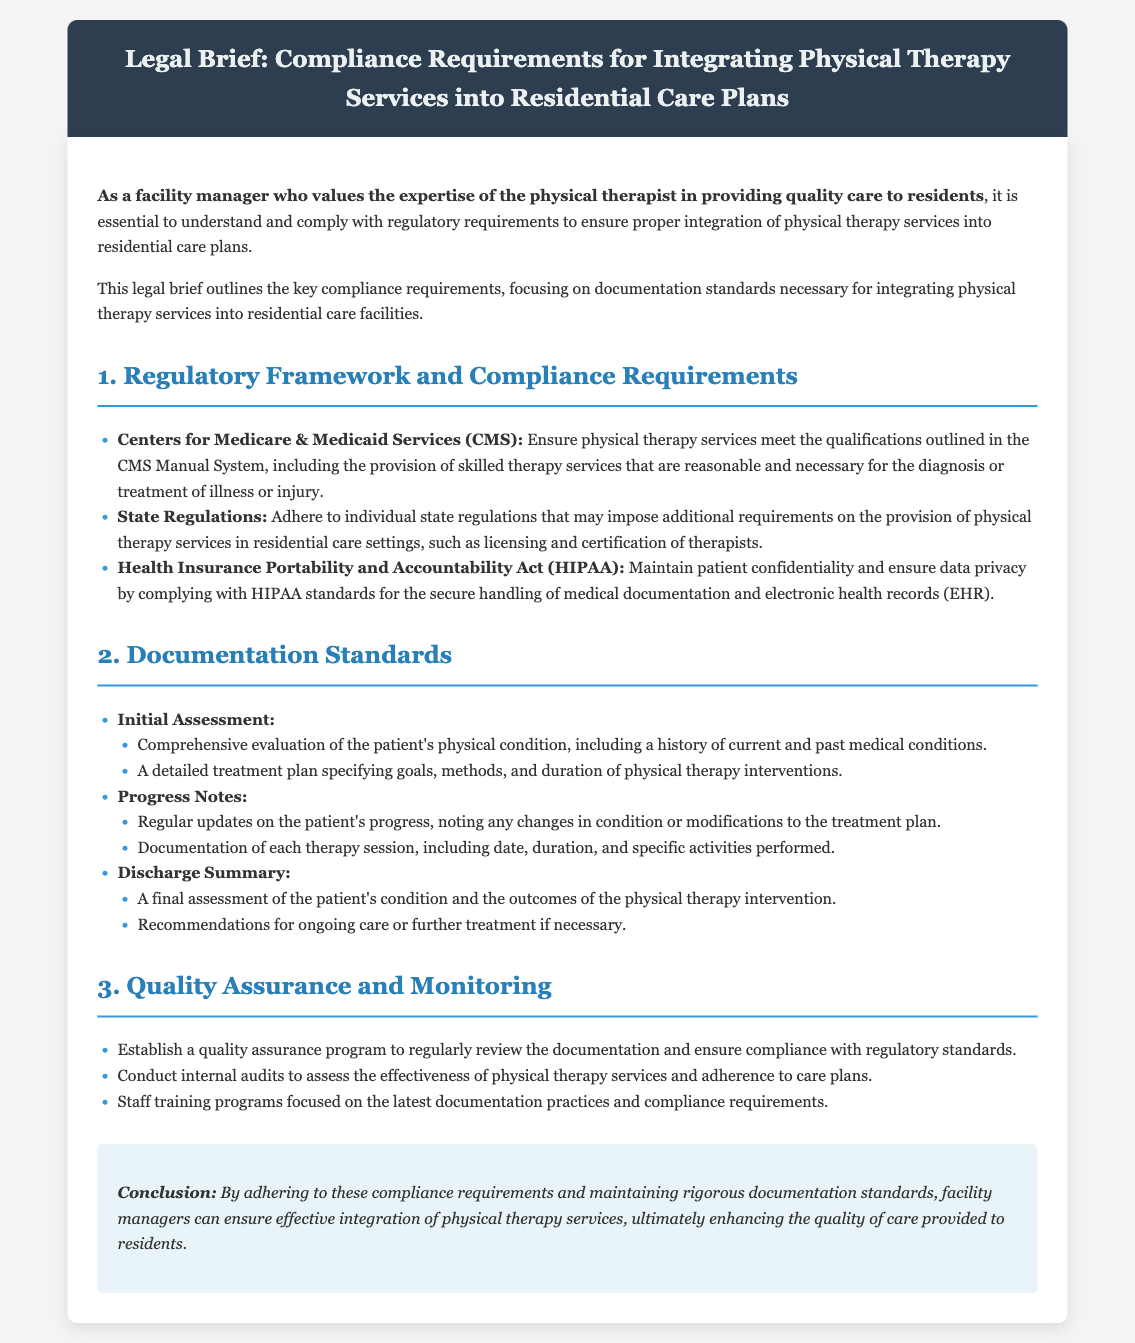What are the key compliance requirements? The key compliance requirements include regulatory frameworks such as CMS guidelines, state regulations, and HIPAA standards.
Answer: CMS, state regulations, HIPAA What is the focus of the documentation standards? The documentation standards focus on the initial assessment, progress notes, and discharge summary for physical therapy services.
Answer: Initial assessment, progress notes, discharge summary Why is patient confidentiality important? Patient confidentiality is important to ensure data privacy and comply with HIPAA standards regarding medical documentation handling.
Answer: Data privacy, HIPAA What is included in the initial assessment? The initial assessment includes a comprehensive evaluation of the patient's physical condition and a detailed treatment plan.
Answer: Evaluation, treatment plan What does the quality assurance program ensure? The quality assurance program ensures compliance with regulatory standards and effective physical therapy service delivery.
Answer: Compliance, effective delivery What type of audits should be conducted? Internal audits should be conducted to assess the effectiveness of physical therapy services and adherence to care plans.
Answer: Internal audits What should the discharge summary include? The discharge summary should include a final assessment of the patient's condition and recommendations for ongoing care.
Answer: Final assessment, recommendations How often should progress notes be updated? Progress notes should be updated regularly to document changes in the patient's condition or treatment modifications.
Answer: Regularly Which agency outlines the qualifications for physical therapy services? The agency that outlines qualifications is the Centers for Medicare & Medicaid Services (CMS).
Answer: Centers for Medicare & Medicaid Services What is the purpose of training programs for staff? The purpose of training programs is to focus on the latest documentation practices and compliance requirements.
Answer: Documentation practices, compliance requirements 